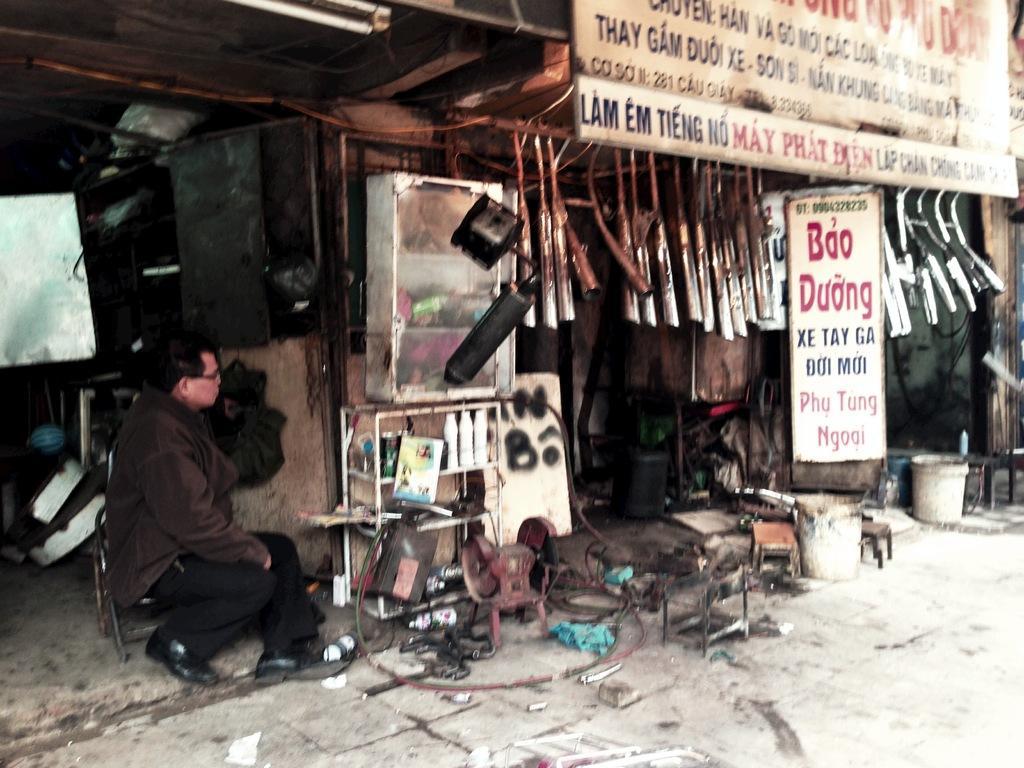Describe this image in one or two sentences. In this image we can see a person sitting on the chair, boards with some text, hanging objects and we can see some objects on the floor. 